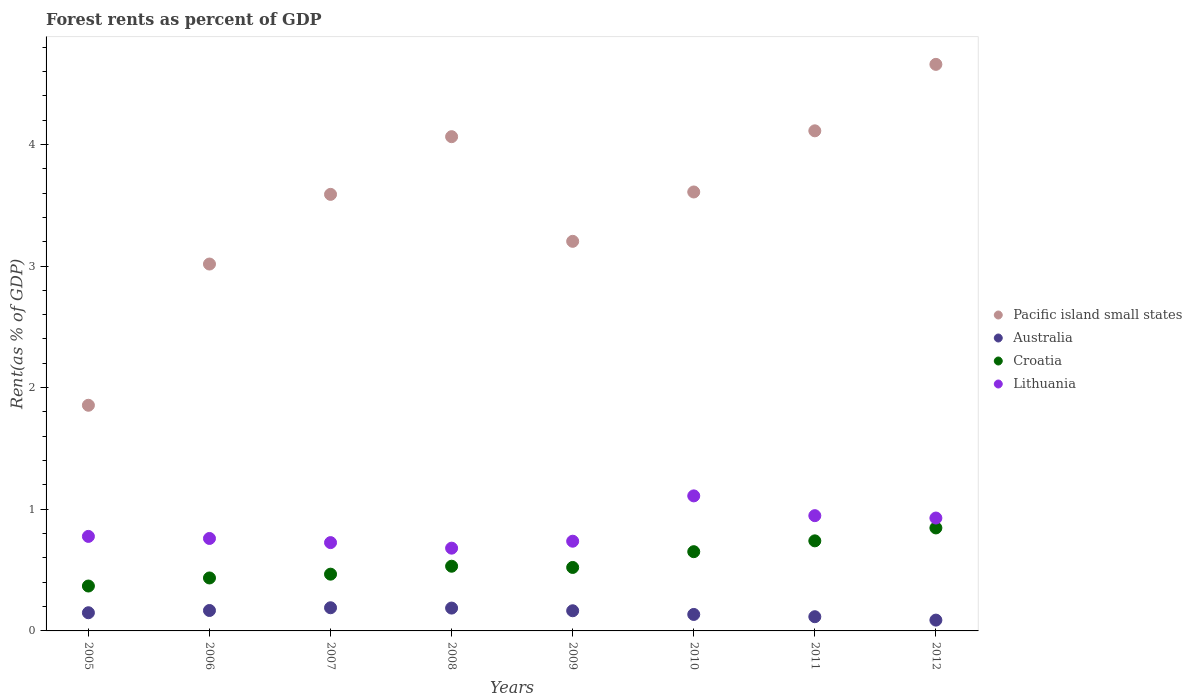How many different coloured dotlines are there?
Offer a very short reply. 4. Is the number of dotlines equal to the number of legend labels?
Keep it short and to the point. Yes. What is the forest rent in Pacific island small states in 2008?
Make the answer very short. 4.06. Across all years, what is the maximum forest rent in Australia?
Your response must be concise. 0.19. Across all years, what is the minimum forest rent in Lithuania?
Offer a very short reply. 0.68. In which year was the forest rent in Pacific island small states maximum?
Provide a short and direct response. 2012. In which year was the forest rent in Lithuania minimum?
Keep it short and to the point. 2008. What is the total forest rent in Lithuania in the graph?
Your response must be concise. 6.67. What is the difference between the forest rent in Lithuania in 2005 and that in 2010?
Offer a very short reply. -0.33. What is the difference between the forest rent in Lithuania in 2005 and the forest rent in Pacific island small states in 2009?
Give a very brief answer. -2.43. What is the average forest rent in Croatia per year?
Keep it short and to the point. 0.57. In the year 2008, what is the difference between the forest rent in Australia and forest rent in Pacific island small states?
Your answer should be very brief. -3.88. What is the ratio of the forest rent in Australia in 2005 to that in 2010?
Provide a succinct answer. 1.1. Is the difference between the forest rent in Australia in 2005 and 2010 greater than the difference between the forest rent in Pacific island small states in 2005 and 2010?
Give a very brief answer. Yes. What is the difference between the highest and the second highest forest rent in Pacific island small states?
Keep it short and to the point. 0.55. What is the difference between the highest and the lowest forest rent in Pacific island small states?
Offer a very short reply. 2.8. In how many years, is the forest rent in Croatia greater than the average forest rent in Croatia taken over all years?
Ensure brevity in your answer.  3. Is the sum of the forest rent in Pacific island small states in 2009 and 2011 greater than the maximum forest rent in Lithuania across all years?
Give a very brief answer. Yes. Is it the case that in every year, the sum of the forest rent in Australia and forest rent in Croatia  is greater than the sum of forest rent in Lithuania and forest rent in Pacific island small states?
Provide a succinct answer. No. Is the forest rent in Pacific island small states strictly greater than the forest rent in Lithuania over the years?
Provide a succinct answer. Yes. How many dotlines are there?
Your answer should be very brief. 4. Are the values on the major ticks of Y-axis written in scientific E-notation?
Your answer should be compact. No. Does the graph contain any zero values?
Keep it short and to the point. No. Where does the legend appear in the graph?
Keep it short and to the point. Center right. What is the title of the graph?
Provide a succinct answer. Forest rents as percent of GDP. What is the label or title of the Y-axis?
Your answer should be very brief. Rent(as % of GDP). What is the Rent(as % of GDP) of Pacific island small states in 2005?
Ensure brevity in your answer.  1.86. What is the Rent(as % of GDP) in Australia in 2005?
Provide a succinct answer. 0.15. What is the Rent(as % of GDP) of Croatia in 2005?
Your response must be concise. 0.37. What is the Rent(as % of GDP) of Lithuania in 2005?
Offer a very short reply. 0.78. What is the Rent(as % of GDP) in Pacific island small states in 2006?
Your answer should be very brief. 3.02. What is the Rent(as % of GDP) of Australia in 2006?
Provide a short and direct response. 0.17. What is the Rent(as % of GDP) in Croatia in 2006?
Make the answer very short. 0.44. What is the Rent(as % of GDP) in Lithuania in 2006?
Give a very brief answer. 0.76. What is the Rent(as % of GDP) in Pacific island small states in 2007?
Your response must be concise. 3.59. What is the Rent(as % of GDP) in Australia in 2007?
Offer a very short reply. 0.19. What is the Rent(as % of GDP) in Croatia in 2007?
Provide a succinct answer. 0.47. What is the Rent(as % of GDP) in Lithuania in 2007?
Offer a terse response. 0.73. What is the Rent(as % of GDP) in Pacific island small states in 2008?
Provide a succinct answer. 4.06. What is the Rent(as % of GDP) of Australia in 2008?
Make the answer very short. 0.19. What is the Rent(as % of GDP) of Croatia in 2008?
Your response must be concise. 0.53. What is the Rent(as % of GDP) of Lithuania in 2008?
Your response must be concise. 0.68. What is the Rent(as % of GDP) in Pacific island small states in 2009?
Your answer should be compact. 3.2. What is the Rent(as % of GDP) of Australia in 2009?
Provide a short and direct response. 0.17. What is the Rent(as % of GDP) of Croatia in 2009?
Keep it short and to the point. 0.52. What is the Rent(as % of GDP) in Lithuania in 2009?
Make the answer very short. 0.74. What is the Rent(as % of GDP) in Pacific island small states in 2010?
Provide a succinct answer. 3.61. What is the Rent(as % of GDP) in Australia in 2010?
Provide a short and direct response. 0.14. What is the Rent(as % of GDP) in Croatia in 2010?
Give a very brief answer. 0.65. What is the Rent(as % of GDP) in Lithuania in 2010?
Provide a short and direct response. 1.11. What is the Rent(as % of GDP) of Pacific island small states in 2011?
Give a very brief answer. 4.11. What is the Rent(as % of GDP) of Australia in 2011?
Provide a succinct answer. 0.12. What is the Rent(as % of GDP) of Croatia in 2011?
Provide a short and direct response. 0.74. What is the Rent(as % of GDP) in Lithuania in 2011?
Ensure brevity in your answer.  0.95. What is the Rent(as % of GDP) of Pacific island small states in 2012?
Offer a very short reply. 4.66. What is the Rent(as % of GDP) in Australia in 2012?
Your answer should be compact. 0.09. What is the Rent(as % of GDP) of Croatia in 2012?
Give a very brief answer. 0.85. What is the Rent(as % of GDP) of Lithuania in 2012?
Your answer should be very brief. 0.93. Across all years, what is the maximum Rent(as % of GDP) in Pacific island small states?
Your response must be concise. 4.66. Across all years, what is the maximum Rent(as % of GDP) of Australia?
Ensure brevity in your answer.  0.19. Across all years, what is the maximum Rent(as % of GDP) of Croatia?
Your answer should be compact. 0.85. Across all years, what is the maximum Rent(as % of GDP) of Lithuania?
Provide a short and direct response. 1.11. Across all years, what is the minimum Rent(as % of GDP) of Pacific island small states?
Offer a terse response. 1.86. Across all years, what is the minimum Rent(as % of GDP) in Australia?
Ensure brevity in your answer.  0.09. Across all years, what is the minimum Rent(as % of GDP) of Croatia?
Your response must be concise. 0.37. Across all years, what is the minimum Rent(as % of GDP) of Lithuania?
Your answer should be very brief. 0.68. What is the total Rent(as % of GDP) of Pacific island small states in the graph?
Provide a short and direct response. 28.1. What is the total Rent(as % of GDP) in Australia in the graph?
Ensure brevity in your answer.  1.2. What is the total Rent(as % of GDP) of Croatia in the graph?
Keep it short and to the point. 4.56. What is the total Rent(as % of GDP) of Lithuania in the graph?
Provide a short and direct response. 6.67. What is the difference between the Rent(as % of GDP) of Pacific island small states in 2005 and that in 2006?
Provide a short and direct response. -1.16. What is the difference between the Rent(as % of GDP) in Australia in 2005 and that in 2006?
Give a very brief answer. -0.02. What is the difference between the Rent(as % of GDP) in Croatia in 2005 and that in 2006?
Offer a terse response. -0.07. What is the difference between the Rent(as % of GDP) in Lithuania in 2005 and that in 2006?
Offer a terse response. 0.02. What is the difference between the Rent(as % of GDP) of Pacific island small states in 2005 and that in 2007?
Your response must be concise. -1.73. What is the difference between the Rent(as % of GDP) in Australia in 2005 and that in 2007?
Keep it short and to the point. -0.04. What is the difference between the Rent(as % of GDP) of Croatia in 2005 and that in 2007?
Provide a short and direct response. -0.1. What is the difference between the Rent(as % of GDP) of Lithuania in 2005 and that in 2007?
Give a very brief answer. 0.05. What is the difference between the Rent(as % of GDP) in Pacific island small states in 2005 and that in 2008?
Your answer should be very brief. -2.21. What is the difference between the Rent(as % of GDP) in Australia in 2005 and that in 2008?
Provide a short and direct response. -0.04. What is the difference between the Rent(as % of GDP) in Croatia in 2005 and that in 2008?
Offer a terse response. -0.16. What is the difference between the Rent(as % of GDP) in Lithuania in 2005 and that in 2008?
Keep it short and to the point. 0.1. What is the difference between the Rent(as % of GDP) in Pacific island small states in 2005 and that in 2009?
Offer a terse response. -1.35. What is the difference between the Rent(as % of GDP) in Australia in 2005 and that in 2009?
Offer a very short reply. -0.02. What is the difference between the Rent(as % of GDP) in Croatia in 2005 and that in 2009?
Provide a succinct answer. -0.15. What is the difference between the Rent(as % of GDP) of Lithuania in 2005 and that in 2009?
Your answer should be compact. 0.04. What is the difference between the Rent(as % of GDP) in Pacific island small states in 2005 and that in 2010?
Offer a very short reply. -1.75. What is the difference between the Rent(as % of GDP) of Australia in 2005 and that in 2010?
Keep it short and to the point. 0.01. What is the difference between the Rent(as % of GDP) of Croatia in 2005 and that in 2010?
Offer a terse response. -0.28. What is the difference between the Rent(as % of GDP) in Lithuania in 2005 and that in 2010?
Offer a very short reply. -0.33. What is the difference between the Rent(as % of GDP) of Pacific island small states in 2005 and that in 2011?
Ensure brevity in your answer.  -2.26. What is the difference between the Rent(as % of GDP) of Australia in 2005 and that in 2011?
Your answer should be compact. 0.03. What is the difference between the Rent(as % of GDP) in Croatia in 2005 and that in 2011?
Your answer should be very brief. -0.37. What is the difference between the Rent(as % of GDP) of Lithuania in 2005 and that in 2011?
Give a very brief answer. -0.17. What is the difference between the Rent(as % of GDP) in Pacific island small states in 2005 and that in 2012?
Your answer should be very brief. -2.8. What is the difference between the Rent(as % of GDP) in Australia in 2005 and that in 2012?
Provide a short and direct response. 0.06. What is the difference between the Rent(as % of GDP) in Croatia in 2005 and that in 2012?
Your response must be concise. -0.48. What is the difference between the Rent(as % of GDP) in Lithuania in 2005 and that in 2012?
Your answer should be compact. -0.15. What is the difference between the Rent(as % of GDP) of Pacific island small states in 2006 and that in 2007?
Provide a short and direct response. -0.57. What is the difference between the Rent(as % of GDP) in Australia in 2006 and that in 2007?
Give a very brief answer. -0.02. What is the difference between the Rent(as % of GDP) of Croatia in 2006 and that in 2007?
Provide a succinct answer. -0.03. What is the difference between the Rent(as % of GDP) in Lithuania in 2006 and that in 2007?
Provide a succinct answer. 0.03. What is the difference between the Rent(as % of GDP) of Pacific island small states in 2006 and that in 2008?
Your answer should be very brief. -1.05. What is the difference between the Rent(as % of GDP) of Australia in 2006 and that in 2008?
Provide a succinct answer. -0.02. What is the difference between the Rent(as % of GDP) in Croatia in 2006 and that in 2008?
Your answer should be compact. -0.1. What is the difference between the Rent(as % of GDP) of Lithuania in 2006 and that in 2008?
Offer a terse response. 0.08. What is the difference between the Rent(as % of GDP) of Pacific island small states in 2006 and that in 2009?
Your response must be concise. -0.19. What is the difference between the Rent(as % of GDP) of Australia in 2006 and that in 2009?
Offer a very short reply. 0. What is the difference between the Rent(as % of GDP) in Croatia in 2006 and that in 2009?
Keep it short and to the point. -0.09. What is the difference between the Rent(as % of GDP) in Lithuania in 2006 and that in 2009?
Offer a terse response. 0.02. What is the difference between the Rent(as % of GDP) of Pacific island small states in 2006 and that in 2010?
Give a very brief answer. -0.59. What is the difference between the Rent(as % of GDP) in Australia in 2006 and that in 2010?
Ensure brevity in your answer.  0.03. What is the difference between the Rent(as % of GDP) in Croatia in 2006 and that in 2010?
Give a very brief answer. -0.22. What is the difference between the Rent(as % of GDP) of Lithuania in 2006 and that in 2010?
Your answer should be very brief. -0.35. What is the difference between the Rent(as % of GDP) in Pacific island small states in 2006 and that in 2011?
Make the answer very short. -1.1. What is the difference between the Rent(as % of GDP) of Australia in 2006 and that in 2011?
Your response must be concise. 0.05. What is the difference between the Rent(as % of GDP) of Croatia in 2006 and that in 2011?
Your response must be concise. -0.31. What is the difference between the Rent(as % of GDP) in Lithuania in 2006 and that in 2011?
Keep it short and to the point. -0.19. What is the difference between the Rent(as % of GDP) of Pacific island small states in 2006 and that in 2012?
Offer a very short reply. -1.64. What is the difference between the Rent(as % of GDP) in Australia in 2006 and that in 2012?
Your answer should be compact. 0.08. What is the difference between the Rent(as % of GDP) in Croatia in 2006 and that in 2012?
Keep it short and to the point. -0.41. What is the difference between the Rent(as % of GDP) in Lithuania in 2006 and that in 2012?
Your answer should be very brief. -0.17. What is the difference between the Rent(as % of GDP) of Pacific island small states in 2007 and that in 2008?
Offer a very short reply. -0.47. What is the difference between the Rent(as % of GDP) in Australia in 2007 and that in 2008?
Your answer should be compact. 0. What is the difference between the Rent(as % of GDP) in Croatia in 2007 and that in 2008?
Keep it short and to the point. -0.07. What is the difference between the Rent(as % of GDP) in Lithuania in 2007 and that in 2008?
Ensure brevity in your answer.  0.05. What is the difference between the Rent(as % of GDP) of Pacific island small states in 2007 and that in 2009?
Your answer should be compact. 0.39. What is the difference between the Rent(as % of GDP) in Australia in 2007 and that in 2009?
Offer a terse response. 0.02. What is the difference between the Rent(as % of GDP) in Croatia in 2007 and that in 2009?
Offer a terse response. -0.06. What is the difference between the Rent(as % of GDP) in Lithuania in 2007 and that in 2009?
Offer a terse response. -0.01. What is the difference between the Rent(as % of GDP) of Pacific island small states in 2007 and that in 2010?
Keep it short and to the point. -0.02. What is the difference between the Rent(as % of GDP) of Australia in 2007 and that in 2010?
Your response must be concise. 0.06. What is the difference between the Rent(as % of GDP) in Croatia in 2007 and that in 2010?
Provide a short and direct response. -0.18. What is the difference between the Rent(as % of GDP) in Lithuania in 2007 and that in 2010?
Make the answer very short. -0.38. What is the difference between the Rent(as % of GDP) in Pacific island small states in 2007 and that in 2011?
Keep it short and to the point. -0.52. What is the difference between the Rent(as % of GDP) of Australia in 2007 and that in 2011?
Ensure brevity in your answer.  0.07. What is the difference between the Rent(as % of GDP) in Croatia in 2007 and that in 2011?
Your response must be concise. -0.27. What is the difference between the Rent(as % of GDP) in Lithuania in 2007 and that in 2011?
Your response must be concise. -0.22. What is the difference between the Rent(as % of GDP) in Pacific island small states in 2007 and that in 2012?
Your answer should be compact. -1.07. What is the difference between the Rent(as % of GDP) in Australia in 2007 and that in 2012?
Your answer should be very brief. 0.1. What is the difference between the Rent(as % of GDP) in Croatia in 2007 and that in 2012?
Provide a short and direct response. -0.38. What is the difference between the Rent(as % of GDP) of Lithuania in 2007 and that in 2012?
Your response must be concise. -0.2. What is the difference between the Rent(as % of GDP) of Pacific island small states in 2008 and that in 2009?
Ensure brevity in your answer.  0.86. What is the difference between the Rent(as % of GDP) of Australia in 2008 and that in 2009?
Offer a very short reply. 0.02. What is the difference between the Rent(as % of GDP) of Croatia in 2008 and that in 2009?
Your response must be concise. 0.01. What is the difference between the Rent(as % of GDP) in Lithuania in 2008 and that in 2009?
Offer a terse response. -0.06. What is the difference between the Rent(as % of GDP) in Pacific island small states in 2008 and that in 2010?
Ensure brevity in your answer.  0.45. What is the difference between the Rent(as % of GDP) of Australia in 2008 and that in 2010?
Offer a very short reply. 0.05. What is the difference between the Rent(as % of GDP) of Croatia in 2008 and that in 2010?
Your response must be concise. -0.12. What is the difference between the Rent(as % of GDP) in Lithuania in 2008 and that in 2010?
Ensure brevity in your answer.  -0.43. What is the difference between the Rent(as % of GDP) in Pacific island small states in 2008 and that in 2011?
Make the answer very short. -0.05. What is the difference between the Rent(as % of GDP) in Australia in 2008 and that in 2011?
Provide a succinct answer. 0.07. What is the difference between the Rent(as % of GDP) in Croatia in 2008 and that in 2011?
Provide a short and direct response. -0.21. What is the difference between the Rent(as % of GDP) in Lithuania in 2008 and that in 2011?
Offer a terse response. -0.27. What is the difference between the Rent(as % of GDP) in Pacific island small states in 2008 and that in 2012?
Your answer should be compact. -0.59. What is the difference between the Rent(as % of GDP) in Australia in 2008 and that in 2012?
Your answer should be compact. 0.1. What is the difference between the Rent(as % of GDP) of Croatia in 2008 and that in 2012?
Your answer should be very brief. -0.31. What is the difference between the Rent(as % of GDP) in Lithuania in 2008 and that in 2012?
Provide a short and direct response. -0.25. What is the difference between the Rent(as % of GDP) of Pacific island small states in 2009 and that in 2010?
Give a very brief answer. -0.41. What is the difference between the Rent(as % of GDP) of Australia in 2009 and that in 2010?
Provide a short and direct response. 0.03. What is the difference between the Rent(as % of GDP) in Croatia in 2009 and that in 2010?
Keep it short and to the point. -0.13. What is the difference between the Rent(as % of GDP) of Lithuania in 2009 and that in 2010?
Provide a succinct answer. -0.37. What is the difference between the Rent(as % of GDP) in Pacific island small states in 2009 and that in 2011?
Your answer should be very brief. -0.91. What is the difference between the Rent(as % of GDP) in Australia in 2009 and that in 2011?
Your answer should be compact. 0.05. What is the difference between the Rent(as % of GDP) of Croatia in 2009 and that in 2011?
Offer a very short reply. -0.22. What is the difference between the Rent(as % of GDP) in Lithuania in 2009 and that in 2011?
Provide a succinct answer. -0.21. What is the difference between the Rent(as % of GDP) in Pacific island small states in 2009 and that in 2012?
Provide a succinct answer. -1.45. What is the difference between the Rent(as % of GDP) of Australia in 2009 and that in 2012?
Make the answer very short. 0.08. What is the difference between the Rent(as % of GDP) of Croatia in 2009 and that in 2012?
Your answer should be compact. -0.32. What is the difference between the Rent(as % of GDP) of Lithuania in 2009 and that in 2012?
Keep it short and to the point. -0.19. What is the difference between the Rent(as % of GDP) of Pacific island small states in 2010 and that in 2011?
Provide a succinct answer. -0.5. What is the difference between the Rent(as % of GDP) in Australia in 2010 and that in 2011?
Give a very brief answer. 0.02. What is the difference between the Rent(as % of GDP) of Croatia in 2010 and that in 2011?
Make the answer very short. -0.09. What is the difference between the Rent(as % of GDP) in Lithuania in 2010 and that in 2011?
Give a very brief answer. 0.16. What is the difference between the Rent(as % of GDP) in Pacific island small states in 2010 and that in 2012?
Keep it short and to the point. -1.05. What is the difference between the Rent(as % of GDP) of Australia in 2010 and that in 2012?
Provide a short and direct response. 0.05. What is the difference between the Rent(as % of GDP) in Croatia in 2010 and that in 2012?
Provide a short and direct response. -0.2. What is the difference between the Rent(as % of GDP) of Lithuania in 2010 and that in 2012?
Your answer should be very brief. 0.18. What is the difference between the Rent(as % of GDP) of Pacific island small states in 2011 and that in 2012?
Your response must be concise. -0.55. What is the difference between the Rent(as % of GDP) of Australia in 2011 and that in 2012?
Give a very brief answer. 0.03. What is the difference between the Rent(as % of GDP) of Croatia in 2011 and that in 2012?
Offer a very short reply. -0.11. What is the difference between the Rent(as % of GDP) in Lithuania in 2011 and that in 2012?
Ensure brevity in your answer.  0.02. What is the difference between the Rent(as % of GDP) of Pacific island small states in 2005 and the Rent(as % of GDP) of Australia in 2006?
Your answer should be very brief. 1.69. What is the difference between the Rent(as % of GDP) in Pacific island small states in 2005 and the Rent(as % of GDP) in Croatia in 2006?
Provide a succinct answer. 1.42. What is the difference between the Rent(as % of GDP) in Pacific island small states in 2005 and the Rent(as % of GDP) in Lithuania in 2006?
Provide a short and direct response. 1.1. What is the difference between the Rent(as % of GDP) of Australia in 2005 and the Rent(as % of GDP) of Croatia in 2006?
Ensure brevity in your answer.  -0.29. What is the difference between the Rent(as % of GDP) in Australia in 2005 and the Rent(as % of GDP) in Lithuania in 2006?
Ensure brevity in your answer.  -0.61. What is the difference between the Rent(as % of GDP) of Croatia in 2005 and the Rent(as % of GDP) of Lithuania in 2006?
Offer a terse response. -0.39. What is the difference between the Rent(as % of GDP) of Pacific island small states in 2005 and the Rent(as % of GDP) of Australia in 2007?
Make the answer very short. 1.66. What is the difference between the Rent(as % of GDP) in Pacific island small states in 2005 and the Rent(as % of GDP) in Croatia in 2007?
Make the answer very short. 1.39. What is the difference between the Rent(as % of GDP) of Pacific island small states in 2005 and the Rent(as % of GDP) of Lithuania in 2007?
Ensure brevity in your answer.  1.13. What is the difference between the Rent(as % of GDP) in Australia in 2005 and the Rent(as % of GDP) in Croatia in 2007?
Give a very brief answer. -0.32. What is the difference between the Rent(as % of GDP) of Australia in 2005 and the Rent(as % of GDP) of Lithuania in 2007?
Provide a short and direct response. -0.58. What is the difference between the Rent(as % of GDP) in Croatia in 2005 and the Rent(as % of GDP) in Lithuania in 2007?
Ensure brevity in your answer.  -0.36. What is the difference between the Rent(as % of GDP) in Pacific island small states in 2005 and the Rent(as % of GDP) in Australia in 2008?
Your answer should be very brief. 1.67. What is the difference between the Rent(as % of GDP) of Pacific island small states in 2005 and the Rent(as % of GDP) of Croatia in 2008?
Your response must be concise. 1.32. What is the difference between the Rent(as % of GDP) in Pacific island small states in 2005 and the Rent(as % of GDP) in Lithuania in 2008?
Your answer should be very brief. 1.17. What is the difference between the Rent(as % of GDP) in Australia in 2005 and the Rent(as % of GDP) in Croatia in 2008?
Provide a short and direct response. -0.38. What is the difference between the Rent(as % of GDP) in Australia in 2005 and the Rent(as % of GDP) in Lithuania in 2008?
Your answer should be compact. -0.53. What is the difference between the Rent(as % of GDP) of Croatia in 2005 and the Rent(as % of GDP) of Lithuania in 2008?
Your response must be concise. -0.31. What is the difference between the Rent(as % of GDP) of Pacific island small states in 2005 and the Rent(as % of GDP) of Australia in 2009?
Give a very brief answer. 1.69. What is the difference between the Rent(as % of GDP) of Pacific island small states in 2005 and the Rent(as % of GDP) of Croatia in 2009?
Offer a very short reply. 1.33. What is the difference between the Rent(as % of GDP) in Pacific island small states in 2005 and the Rent(as % of GDP) in Lithuania in 2009?
Your answer should be compact. 1.12. What is the difference between the Rent(as % of GDP) of Australia in 2005 and the Rent(as % of GDP) of Croatia in 2009?
Provide a succinct answer. -0.37. What is the difference between the Rent(as % of GDP) in Australia in 2005 and the Rent(as % of GDP) in Lithuania in 2009?
Your answer should be compact. -0.59. What is the difference between the Rent(as % of GDP) of Croatia in 2005 and the Rent(as % of GDP) of Lithuania in 2009?
Your answer should be very brief. -0.37. What is the difference between the Rent(as % of GDP) of Pacific island small states in 2005 and the Rent(as % of GDP) of Australia in 2010?
Provide a short and direct response. 1.72. What is the difference between the Rent(as % of GDP) of Pacific island small states in 2005 and the Rent(as % of GDP) of Croatia in 2010?
Offer a very short reply. 1.2. What is the difference between the Rent(as % of GDP) of Pacific island small states in 2005 and the Rent(as % of GDP) of Lithuania in 2010?
Your response must be concise. 0.74. What is the difference between the Rent(as % of GDP) in Australia in 2005 and the Rent(as % of GDP) in Croatia in 2010?
Offer a very short reply. -0.5. What is the difference between the Rent(as % of GDP) in Australia in 2005 and the Rent(as % of GDP) in Lithuania in 2010?
Give a very brief answer. -0.96. What is the difference between the Rent(as % of GDP) of Croatia in 2005 and the Rent(as % of GDP) of Lithuania in 2010?
Provide a succinct answer. -0.74. What is the difference between the Rent(as % of GDP) of Pacific island small states in 2005 and the Rent(as % of GDP) of Australia in 2011?
Offer a terse response. 1.74. What is the difference between the Rent(as % of GDP) in Pacific island small states in 2005 and the Rent(as % of GDP) in Croatia in 2011?
Offer a terse response. 1.11. What is the difference between the Rent(as % of GDP) of Pacific island small states in 2005 and the Rent(as % of GDP) of Lithuania in 2011?
Offer a terse response. 0.91. What is the difference between the Rent(as % of GDP) of Australia in 2005 and the Rent(as % of GDP) of Croatia in 2011?
Your response must be concise. -0.59. What is the difference between the Rent(as % of GDP) of Australia in 2005 and the Rent(as % of GDP) of Lithuania in 2011?
Your answer should be very brief. -0.8. What is the difference between the Rent(as % of GDP) of Croatia in 2005 and the Rent(as % of GDP) of Lithuania in 2011?
Ensure brevity in your answer.  -0.58. What is the difference between the Rent(as % of GDP) of Pacific island small states in 2005 and the Rent(as % of GDP) of Australia in 2012?
Make the answer very short. 1.77. What is the difference between the Rent(as % of GDP) in Pacific island small states in 2005 and the Rent(as % of GDP) in Croatia in 2012?
Your answer should be very brief. 1.01. What is the difference between the Rent(as % of GDP) of Pacific island small states in 2005 and the Rent(as % of GDP) of Lithuania in 2012?
Offer a very short reply. 0.93. What is the difference between the Rent(as % of GDP) in Australia in 2005 and the Rent(as % of GDP) in Croatia in 2012?
Your response must be concise. -0.7. What is the difference between the Rent(as % of GDP) of Australia in 2005 and the Rent(as % of GDP) of Lithuania in 2012?
Your answer should be very brief. -0.78. What is the difference between the Rent(as % of GDP) of Croatia in 2005 and the Rent(as % of GDP) of Lithuania in 2012?
Keep it short and to the point. -0.56. What is the difference between the Rent(as % of GDP) of Pacific island small states in 2006 and the Rent(as % of GDP) of Australia in 2007?
Your answer should be compact. 2.83. What is the difference between the Rent(as % of GDP) in Pacific island small states in 2006 and the Rent(as % of GDP) in Croatia in 2007?
Give a very brief answer. 2.55. What is the difference between the Rent(as % of GDP) in Pacific island small states in 2006 and the Rent(as % of GDP) in Lithuania in 2007?
Offer a very short reply. 2.29. What is the difference between the Rent(as % of GDP) of Australia in 2006 and the Rent(as % of GDP) of Croatia in 2007?
Your answer should be compact. -0.3. What is the difference between the Rent(as % of GDP) of Australia in 2006 and the Rent(as % of GDP) of Lithuania in 2007?
Your response must be concise. -0.56. What is the difference between the Rent(as % of GDP) of Croatia in 2006 and the Rent(as % of GDP) of Lithuania in 2007?
Your answer should be compact. -0.29. What is the difference between the Rent(as % of GDP) of Pacific island small states in 2006 and the Rent(as % of GDP) of Australia in 2008?
Offer a very short reply. 2.83. What is the difference between the Rent(as % of GDP) of Pacific island small states in 2006 and the Rent(as % of GDP) of Croatia in 2008?
Provide a succinct answer. 2.48. What is the difference between the Rent(as % of GDP) in Pacific island small states in 2006 and the Rent(as % of GDP) in Lithuania in 2008?
Provide a short and direct response. 2.34. What is the difference between the Rent(as % of GDP) of Australia in 2006 and the Rent(as % of GDP) of Croatia in 2008?
Provide a succinct answer. -0.36. What is the difference between the Rent(as % of GDP) in Australia in 2006 and the Rent(as % of GDP) in Lithuania in 2008?
Offer a terse response. -0.51. What is the difference between the Rent(as % of GDP) of Croatia in 2006 and the Rent(as % of GDP) of Lithuania in 2008?
Provide a succinct answer. -0.24. What is the difference between the Rent(as % of GDP) of Pacific island small states in 2006 and the Rent(as % of GDP) of Australia in 2009?
Make the answer very short. 2.85. What is the difference between the Rent(as % of GDP) in Pacific island small states in 2006 and the Rent(as % of GDP) in Croatia in 2009?
Make the answer very short. 2.49. What is the difference between the Rent(as % of GDP) in Pacific island small states in 2006 and the Rent(as % of GDP) in Lithuania in 2009?
Make the answer very short. 2.28. What is the difference between the Rent(as % of GDP) of Australia in 2006 and the Rent(as % of GDP) of Croatia in 2009?
Ensure brevity in your answer.  -0.35. What is the difference between the Rent(as % of GDP) in Australia in 2006 and the Rent(as % of GDP) in Lithuania in 2009?
Your answer should be very brief. -0.57. What is the difference between the Rent(as % of GDP) in Croatia in 2006 and the Rent(as % of GDP) in Lithuania in 2009?
Your answer should be very brief. -0.3. What is the difference between the Rent(as % of GDP) of Pacific island small states in 2006 and the Rent(as % of GDP) of Australia in 2010?
Give a very brief answer. 2.88. What is the difference between the Rent(as % of GDP) in Pacific island small states in 2006 and the Rent(as % of GDP) in Croatia in 2010?
Give a very brief answer. 2.36. What is the difference between the Rent(as % of GDP) in Pacific island small states in 2006 and the Rent(as % of GDP) in Lithuania in 2010?
Your answer should be very brief. 1.91. What is the difference between the Rent(as % of GDP) in Australia in 2006 and the Rent(as % of GDP) in Croatia in 2010?
Keep it short and to the point. -0.48. What is the difference between the Rent(as % of GDP) of Australia in 2006 and the Rent(as % of GDP) of Lithuania in 2010?
Offer a very short reply. -0.94. What is the difference between the Rent(as % of GDP) in Croatia in 2006 and the Rent(as % of GDP) in Lithuania in 2010?
Offer a very short reply. -0.67. What is the difference between the Rent(as % of GDP) of Pacific island small states in 2006 and the Rent(as % of GDP) of Australia in 2011?
Give a very brief answer. 2.9. What is the difference between the Rent(as % of GDP) of Pacific island small states in 2006 and the Rent(as % of GDP) of Croatia in 2011?
Ensure brevity in your answer.  2.28. What is the difference between the Rent(as % of GDP) of Pacific island small states in 2006 and the Rent(as % of GDP) of Lithuania in 2011?
Keep it short and to the point. 2.07. What is the difference between the Rent(as % of GDP) of Australia in 2006 and the Rent(as % of GDP) of Croatia in 2011?
Offer a very short reply. -0.57. What is the difference between the Rent(as % of GDP) of Australia in 2006 and the Rent(as % of GDP) of Lithuania in 2011?
Ensure brevity in your answer.  -0.78. What is the difference between the Rent(as % of GDP) in Croatia in 2006 and the Rent(as % of GDP) in Lithuania in 2011?
Offer a very short reply. -0.51. What is the difference between the Rent(as % of GDP) of Pacific island small states in 2006 and the Rent(as % of GDP) of Australia in 2012?
Make the answer very short. 2.93. What is the difference between the Rent(as % of GDP) in Pacific island small states in 2006 and the Rent(as % of GDP) in Croatia in 2012?
Your answer should be compact. 2.17. What is the difference between the Rent(as % of GDP) of Pacific island small states in 2006 and the Rent(as % of GDP) of Lithuania in 2012?
Keep it short and to the point. 2.09. What is the difference between the Rent(as % of GDP) of Australia in 2006 and the Rent(as % of GDP) of Croatia in 2012?
Make the answer very short. -0.68. What is the difference between the Rent(as % of GDP) in Australia in 2006 and the Rent(as % of GDP) in Lithuania in 2012?
Your response must be concise. -0.76. What is the difference between the Rent(as % of GDP) in Croatia in 2006 and the Rent(as % of GDP) in Lithuania in 2012?
Offer a terse response. -0.49. What is the difference between the Rent(as % of GDP) in Pacific island small states in 2007 and the Rent(as % of GDP) in Australia in 2008?
Offer a terse response. 3.4. What is the difference between the Rent(as % of GDP) in Pacific island small states in 2007 and the Rent(as % of GDP) in Croatia in 2008?
Your answer should be compact. 3.06. What is the difference between the Rent(as % of GDP) in Pacific island small states in 2007 and the Rent(as % of GDP) in Lithuania in 2008?
Offer a terse response. 2.91. What is the difference between the Rent(as % of GDP) in Australia in 2007 and the Rent(as % of GDP) in Croatia in 2008?
Ensure brevity in your answer.  -0.34. What is the difference between the Rent(as % of GDP) of Australia in 2007 and the Rent(as % of GDP) of Lithuania in 2008?
Keep it short and to the point. -0.49. What is the difference between the Rent(as % of GDP) of Croatia in 2007 and the Rent(as % of GDP) of Lithuania in 2008?
Your answer should be very brief. -0.21. What is the difference between the Rent(as % of GDP) in Pacific island small states in 2007 and the Rent(as % of GDP) in Australia in 2009?
Provide a short and direct response. 3.42. What is the difference between the Rent(as % of GDP) of Pacific island small states in 2007 and the Rent(as % of GDP) of Croatia in 2009?
Your response must be concise. 3.07. What is the difference between the Rent(as % of GDP) in Pacific island small states in 2007 and the Rent(as % of GDP) in Lithuania in 2009?
Give a very brief answer. 2.85. What is the difference between the Rent(as % of GDP) of Australia in 2007 and the Rent(as % of GDP) of Croatia in 2009?
Provide a succinct answer. -0.33. What is the difference between the Rent(as % of GDP) of Australia in 2007 and the Rent(as % of GDP) of Lithuania in 2009?
Your response must be concise. -0.55. What is the difference between the Rent(as % of GDP) in Croatia in 2007 and the Rent(as % of GDP) in Lithuania in 2009?
Your answer should be compact. -0.27. What is the difference between the Rent(as % of GDP) in Pacific island small states in 2007 and the Rent(as % of GDP) in Australia in 2010?
Give a very brief answer. 3.45. What is the difference between the Rent(as % of GDP) in Pacific island small states in 2007 and the Rent(as % of GDP) in Croatia in 2010?
Your answer should be compact. 2.94. What is the difference between the Rent(as % of GDP) in Pacific island small states in 2007 and the Rent(as % of GDP) in Lithuania in 2010?
Your response must be concise. 2.48. What is the difference between the Rent(as % of GDP) in Australia in 2007 and the Rent(as % of GDP) in Croatia in 2010?
Your response must be concise. -0.46. What is the difference between the Rent(as % of GDP) in Australia in 2007 and the Rent(as % of GDP) in Lithuania in 2010?
Provide a succinct answer. -0.92. What is the difference between the Rent(as % of GDP) in Croatia in 2007 and the Rent(as % of GDP) in Lithuania in 2010?
Provide a succinct answer. -0.64. What is the difference between the Rent(as % of GDP) in Pacific island small states in 2007 and the Rent(as % of GDP) in Australia in 2011?
Offer a terse response. 3.47. What is the difference between the Rent(as % of GDP) in Pacific island small states in 2007 and the Rent(as % of GDP) in Croatia in 2011?
Keep it short and to the point. 2.85. What is the difference between the Rent(as % of GDP) of Pacific island small states in 2007 and the Rent(as % of GDP) of Lithuania in 2011?
Give a very brief answer. 2.64. What is the difference between the Rent(as % of GDP) of Australia in 2007 and the Rent(as % of GDP) of Croatia in 2011?
Provide a succinct answer. -0.55. What is the difference between the Rent(as % of GDP) of Australia in 2007 and the Rent(as % of GDP) of Lithuania in 2011?
Provide a succinct answer. -0.76. What is the difference between the Rent(as % of GDP) of Croatia in 2007 and the Rent(as % of GDP) of Lithuania in 2011?
Give a very brief answer. -0.48. What is the difference between the Rent(as % of GDP) in Pacific island small states in 2007 and the Rent(as % of GDP) in Australia in 2012?
Your answer should be compact. 3.5. What is the difference between the Rent(as % of GDP) of Pacific island small states in 2007 and the Rent(as % of GDP) of Croatia in 2012?
Offer a terse response. 2.74. What is the difference between the Rent(as % of GDP) of Pacific island small states in 2007 and the Rent(as % of GDP) of Lithuania in 2012?
Your answer should be compact. 2.66. What is the difference between the Rent(as % of GDP) in Australia in 2007 and the Rent(as % of GDP) in Croatia in 2012?
Ensure brevity in your answer.  -0.66. What is the difference between the Rent(as % of GDP) of Australia in 2007 and the Rent(as % of GDP) of Lithuania in 2012?
Provide a short and direct response. -0.74. What is the difference between the Rent(as % of GDP) in Croatia in 2007 and the Rent(as % of GDP) in Lithuania in 2012?
Your answer should be compact. -0.46. What is the difference between the Rent(as % of GDP) of Pacific island small states in 2008 and the Rent(as % of GDP) of Australia in 2009?
Offer a very short reply. 3.9. What is the difference between the Rent(as % of GDP) of Pacific island small states in 2008 and the Rent(as % of GDP) of Croatia in 2009?
Keep it short and to the point. 3.54. What is the difference between the Rent(as % of GDP) of Pacific island small states in 2008 and the Rent(as % of GDP) of Lithuania in 2009?
Your response must be concise. 3.33. What is the difference between the Rent(as % of GDP) of Australia in 2008 and the Rent(as % of GDP) of Croatia in 2009?
Your response must be concise. -0.33. What is the difference between the Rent(as % of GDP) in Australia in 2008 and the Rent(as % of GDP) in Lithuania in 2009?
Offer a very short reply. -0.55. What is the difference between the Rent(as % of GDP) in Croatia in 2008 and the Rent(as % of GDP) in Lithuania in 2009?
Give a very brief answer. -0.21. What is the difference between the Rent(as % of GDP) in Pacific island small states in 2008 and the Rent(as % of GDP) in Australia in 2010?
Your answer should be very brief. 3.93. What is the difference between the Rent(as % of GDP) of Pacific island small states in 2008 and the Rent(as % of GDP) of Croatia in 2010?
Your answer should be very brief. 3.41. What is the difference between the Rent(as % of GDP) in Pacific island small states in 2008 and the Rent(as % of GDP) in Lithuania in 2010?
Your response must be concise. 2.95. What is the difference between the Rent(as % of GDP) in Australia in 2008 and the Rent(as % of GDP) in Croatia in 2010?
Provide a short and direct response. -0.46. What is the difference between the Rent(as % of GDP) of Australia in 2008 and the Rent(as % of GDP) of Lithuania in 2010?
Keep it short and to the point. -0.92. What is the difference between the Rent(as % of GDP) in Croatia in 2008 and the Rent(as % of GDP) in Lithuania in 2010?
Offer a very short reply. -0.58. What is the difference between the Rent(as % of GDP) in Pacific island small states in 2008 and the Rent(as % of GDP) in Australia in 2011?
Offer a terse response. 3.95. What is the difference between the Rent(as % of GDP) of Pacific island small states in 2008 and the Rent(as % of GDP) of Croatia in 2011?
Your answer should be very brief. 3.32. What is the difference between the Rent(as % of GDP) of Pacific island small states in 2008 and the Rent(as % of GDP) of Lithuania in 2011?
Your answer should be very brief. 3.12. What is the difference between the Rent(as % of GDP) of Australia in 2008 and the Rent(as % of GDP) of Croatia in 2011?
Offer a very short reply. -0.55. What is the difference between the Rent(as % of GDP) of Australia in 2008 and the Rent(as % of GDP) of Lithuania in 2011?
Your answer should be compact. -0.76. What is the difference between the Rent(as % of GDP) in Croatia in 2008 and the Rent(as % of GDP) in Lithuania in 2011?
Offer a very short reply. -0.42. What is the difference between the Rent(as % of GDP) of Pacific island small states in 2008 and the Rent(as % of GDP) of Australia in 2012?
Provide a short and direct response. 3.97. What is the difference between the Rent(as % of GDP) in Pacific island small states in 2008 and the Rent(as % of GDP) in Croatia in 2012?
Offer a terse response. 3.22. What is the difference between the Rent(as % of GDP) in Pacific island small states in 2008 and the Rent(as % of GDP) in Lithuania in 2012?
Make the answer very short. 3.14. What is the difference between the Rent(as % of GDP) of Australia in 2008 and the Rent(as % of GDP) of Croatia in 2012?
Provide a succinct answer. -0.66. What is the difference between the Rent(as % of GDP) of Australia in 2008 and the Rent(as % of GDP) of Lithuania in 2012?
Provide a short and direct response. -0.74. What is the difference between the Rent(as % of GDP) in Croatia in 2008 and the Rent(as % of GDP) in Lithuania in 2012?
Provide a succinct answer. -0.4. What is the difference between the Rent(as % of GDP) in Pacific island small states in 2009 and the Rent(as % of GDP) in Australia in 2010?
Offer a terse response. 3.07. What is the difference between the Rent(as % of GDP) in Pacific island small states in 2009 and the Rent(as % of GDP) in Croatia in 2010?
Your answer should be very brief. 2.55. What is the difference between the Rent(as % of GDP) of Pacific island small states in 2009 and the Rent(as % of GDP) of Lithuania in 2010?
Give a very brief answer. 2.09. What is the difference between the Rent(as % of GDP) in Australia in 2009 and the Rent(as % of GDP) in Croatia in 2010?
Ensure brevity in your answer.  -0.49. What is the difference between the Rent(as % of GDP) of Australia in 2009 and the Rent(as % of GDP) of Lithuania in 2010?
Offer a terse response. -0.94. What is the difference between the Rent(as % of GDP) of Croatia in 2009 and the Rent(as % of GDP) of Lithuania in 2010?
Give a very brief answer. -0.59. What is the difference between the Rent(as % of GDP) of Pacific island small states in 2009 and the Rent(as % of GDP) of Australia in 2011?
Keep it short and to the point. 3.09. What is the difference between the Rent(as % of GDP) of Pacific island small states in 2009 and the Rent(as % of GDP) of Croatia in 2011?
Provide a succinct answer. 2.46. What is the difference between the Rent(as % of GDP) in Pacific island small states in 2009 and the Rent(as % of GDP) in Lithuania in 2011?
Your response must be concise. 2.26. What is the difference between the Rent(as % of GDP) in Australia in 2009 and the Rent(as % of GDP) in Croatia in 2011?
Give a very brief answer. -0.57. What is the difference between the Rent(as % of GDP) in Australia in 2009 and the Rent(as % of GDP) in Lithuania in 2011?
Make the answer very short. -0.78. What is the difference between the Rent(as % of GDP) in Croatia in 2009 and the Rent(as % of GDP) in Lithuania in 2011?
Your answer should be very brief. -0.43. What is the difference between the Rent(as % of GDP) of Pacific island small states in 2009 and the Rent(as % of GDP) of Australia in 2012?
Your answer should be very brief. 3.11. What is the difference between the Rent(as % of GDP) in Pacific island small states in 2009 and the Rent(as % of GDP) in Croatia in 2012?
Your response must be concise. 2.36. What is the difference between the Rent(as % of GDP) of Pacific island small states in 2009 and the Rent(as % of GDP) of Lithuania in 2012?
Your answer should be compact. 2.27. What is the difference between the Rent(as % of GDP) in Australia in 2009 and the Rent(as % of GDP) in Croatia in 2012?
Give a very brief answer. -0.68. What is the difference between the Rent(as % of GDP) in Australia in 2009 and the Rent(as % of GDP) in Lithuania in 2012?
Your answer should be very brief. -0.76. What is the difference between the Rent(as % of GDP) of Croatia in 2009 and the Rent(as % of GDP) of Lithuania in 2012?
Provide a short and direct response. -0.41. What is the difference between the Rent(as % of GDP) of Pacific island small states in 2010 and the Rent(as % of GDP) of Australia in 2011?
Give a very brief answer. 3.49. What is the difference between the Rent(as % of GDP) in Pacific island small states in 2010 and the Rent(as % of GDP) in Croatia in 2011?
Your answer should be compact. 2.87. What is the difference between the Rent(as % of GDP) of Pacific island small states in 2010 and the Rent(as % of GDP) of Lithuania in 2011?
Your answer should be very brief. 2.66. What is the difference between the Rent(as % of GDP) of Australia in 2010 and the Rent(as % of GDP) of Croatia in 2011?
Make the answer very short. -0.61. What is the difference between the Rent(as % of GDP) of Australia in 2010 and the Rent(as % of GDP) of Lithuania in 2011?
Make the answer very short. -0.81. What is the difference between the Rent(as % of GDP) of Croatia in 2010 and the Rent(as % of GDP) of Lithuania in 2011?
Make the answer very short. -0.3. What is the difference between the Rent(as % of GDP) of Pacific island small states in 2010 and the Rent(as % of GDP) of Australia in 2012?
Your answer should be compact. 3.52. What is the difference between the Rent(as % of GDP) of Pacific island small states in 2010 and the Rent(as % of GDP) of Croatia in 2012?
Provide a short and direct response. 2.76. What is the difference between the Rent(as % of GDP) in Pacific island small states in 2010 and the Rent(as % of GDP) in Lithuania in 2012?
Your answer should be compact. 2.68. What is the difference between the Rent(as % of GDP) of Australia in 2010 and the Rent(as % of GDP) of Croatia in 2012?
Keep it short and to the point. -0.71. What is the difference between the Rent(as % of GDP) of Australia in 2010 and the Rent(as % of GDP) of Lithuania in 2012?
Offer a very short reply. -0.79. What is the difference between the Rent(as % of GDP) of Croatia in 2010 and the Rent(as % of GDP) of Lithuania in 2012?
Your answer should be very brief. -0.28. What is the difference between the Rent(as % of GDP) in Pacific island small states in 2011 and the Rent(as % of GDP) in Australia in 2012?
Your response must be concise. 4.02. What is the difference between the Rent(as % of GDP) of Pacific island small states in 2011 and the Rent(as % of GDP) of Croatia in 2012?
Provide a short and direct response. 3.26. What is the difference between the Rent(as % of GDP) of Pacific island small states in 2011 and the Rent(as % of GDP) of Lithuania in 2012?
Give a very brief answer. 3.18. What is the difference between the Rent(as % of GDP) of Australia in 2011 and the Rent(as % of GDP) of Croatia in 2012?
Provide a succinct answer. -0.73. What is the difference between the Rent(as % of GDP) of Australia in 2011 and the Rent(as % of GDP) of Lithuania in 2012?
Offer a terse response. -0.81. What is the difference between the Rent(as % of GDP) in Croatia in 2011 and the Rent(as % of GDP) in Lithuania in 2012?
Provide a succinct answer. -0.19. What is the average Rent(as % of GDP) of Pacific island small states per year?
Keep it short and to the point. 3.51. What is the average Rent(as % of GDP) of Australia per year?
Ensure brevity in your answer.  0.15. What is the average Rent(as % of GDP) of Croatia per year?
Your response must be concise. 0.57. What is the average Rent(as % of GDP) in Lithuania per year?
Make the answer very short. 0.83. In the year 2005, what is the difference between the Rent(as % of GDP) in Pacific island small states and Rent(as % of GDP) in Australia?
Keep it short and to the point. 1.71. In the year 2005, what is the difference between the Rent(as % of GDP) of Pacific island small states and Rent(as % of GDP) of Croatia?
Offer a terse response. 1.49. In the year 2005, what is the difference between the Rent(as % of GDP) of Pacific island small states and Rent(as % of GDP) of Lithuania?
Keep it short and to the point. 1.08. In the year 2005, what is the difference between the Rent(as % of GDP) of Australia and Rent(as % of GDP) of Croatia?
Provide a succinct answer. -0.22. In the year 2005, what is the difference between the Rent(as % of GDP) of Australia and Rent(as % of GDP) of Lithuania?
Provide a short and direct response. -0.63. In the year 2005, what is the difference between the Rent(as % of GDP) in Croatia and Rent(as % of GDP) in Lithuania?
Offer a terse response. -0.41. In the year 2006, what is the difference between the Rent(as % of GDP) in Pacific island small states and Rent(as % of GDP) in Australia?
Provide a succinct answer. 2.85. In the year 2006, what is the difference between the Rent(as % of GDP) of Pacific island small states and Rent(as % of GDP) of Croatia?
Your answer should be compact. 2.58. In the year 2006, what is the difference between the Rent(as % of GDP) in Pacific island small states and Rent(as % of GDP) in Lithuania?
Offer a terse response. 2.26. In the year 2006, what is the difference between the Rent(as % of GDP) of Australia and Rent(as % of GDP) of Croatia?
Provide a succinct answer. -0.27. In the year 2006, what is the difference between the Rent(as % of GDP) of Australia and Rent(as % of GDP) of Lithuania?
Make the answer very short. -0.59. In the year 2006, what is the difference between the Rent(as % of GDP) in Croatia and Rent(as % of GDP) in Lithuania?
Provide a short and direct response. -0.32. In the year 2007, what is the difference between the Rent(as % of GDP) of Pacific island small states and Rent(as % of GDP) of Australia?
Provide a short and direct response. 3.4. In the year 2007, what is the difference between the Rent(as % of GDP) of Pacific island small states and Rent(as % of GDP) of Croatia?
Your response must be concise. 3.12. In the year 2007, what is the difference between the Rent(as % of GDP) in Pacific island small states and Rent(as % of GDP) in Lithuania?
Offer a terse response. 2.86. In the year 2007, what is the difference between the Rent(as % of GDP) in Australia and Rent(as % of GDP) in Croatia?
Keep it short and to the point. -0.28. In the year 2007, what is the difference between the Rent(as % of GDP) in Australia and Rent(as % of GDP) in Lithuania?
Ensure brevity in your answer.  -0.54. In the year 2007, what is the difference between the Rent(as % of GDP) in Croatia and Rent(as % of GDP) in Lithuania?
Your answer should be compact. -0.26. In the year 2008, what is the difference between the Rent(as % of GDP) of Pacific island small states and Rent(as % of GDP) of Australia?
Offer a very short reply. 3.88. In the year 2008, what is the difference between the Rent(as % of GDP) of Pacific island small states and Rent(as % of GDP) of Croatia?
Offer a very short reply. 3.53. In the year 2008, what is the difference between the Rent(as % of GDP) in Pacific island small states and Rent(as % of GDP) in Lithuania?
Offer a terse response. 3.38. In the year 2008, what is the difference between the Rent(as % of GDP) of Australia and Rent(as % of GDP) of Croatia?
Your answer should be very brief. -0.34. In the year 2008, what is the difference between the Rent(as % of GDP) of Australia and Rent(as % of GDP) of Lithuania?
Ensure brevity in your answer.  -0.49. In the year 2008, what is the difference between the Rent(as % of GDP) in Croatia and Rent(as % of GDP) in Lithuania?
Provide a short and direct response. -0.15. In the year 2009, what is the difference between the Rent(as % of GDP) of Pacific island small states and Rent(as % of GDP) of Australia?
Offer a terse response. 3.04. In the year 2009, what is the difference between the Rent(as % of GDP) in Pacific island small states and Rent(as % of GDP) in Croatia?
Give a very brief answer. 2.68. In the year 2009, what is the difference between the Rent(as % of GDP) in Pacific island small states and Rent(as % of GDP) in Lithuania?
Your answer should be very brief. 2.47. In the year 2009, what is the difference between the Rent(as % of GDP) in Australia and Rent(as % of GDP) in Croatia?
Your answer should be compact. -0.36. In the year 2009, what is the difference between the Rent(as % of GDP) of Australia and Rent(as % of GDP) of Lithuania?
Keep it short and to the point. -0.57. In the year 2009, what is the difference between the Rent(as % of GDP) in Croatia and Rent(as % of GDP) in Lithuania?
Give a very brief answer. -0.22. In the year 2010, what is the difference between the Rent(as % of GDP) in Pacific island small states and Rent(as % of GDP) in Australia?
Provide a succinct answer. 3.47. In the year 2010, what is the difference between the Rent(as % of GDP) of Pacific island small states and Rent(as % of GDP) of Croatia?
Your answer should be very brief. 2.96. In the year 2010, what is the difference between the Rent(as % of GDP) of Pacific island small states and Rent(as % of GDP) of Lithuania?
Ensure brevity in your answer.  2.5. In the year 2010, what is the difference between the Rent(as % of GDP) of Australia and Rent(as % of GDP) of Croatia?
Provide a short and direct response. -0.52. In the year 2010, what is the difference between the Rent(as % of GDP) in Australia and Rent(as % of GDP) in Lithuania?
Keep it short and to the point. -0.97. In the year 2010, what is the difference between the Rent(as % of GDP) of Croatia and Rent(as % of GDP) of Lithuania?
Your answer should be compact. -0.46. In the year 2011, what is the difference between the Rent(as % of GDP) of Pacific island small states and Rent(as % of GDP) of Australia?
Offer a very short reply. 3.99. In the year 2011, what is the difference between the Rent(as % of GDP) of Pacific island small states and Rent(as % of GDP) of Croatia?
Keep it short and to the point. 3.37. In the year 2011, what is the difference between the Rent(as % of GDP) of Pacific island small states and Rent(as % of GDP) of Lithuania?
Make the answer very short. 3.16. In the year 2011, what is the difference between the Rent(as % of GDP) of Australia and Rent(as % of GDP) of Croatia?
Ensure brevity in your answer.  -0.62. In the year 2011, what is the difference between the Rent(as % of GDP) of Australia and Rent(as % of GDP) of Lithuania?
Provide a short and direct response. -0.83. In the year 2011, what is the difference between the Rent(as % of GDP) in Croatia and Rent(as % of GDP) in Lithuania?
Ensure brevity in your answer.  -0.21. In the year 2012, what is the difference between the Rent(as % of GDP) in Pacific island small states and Rent(as % of GDP) in Australia?
Make the answer very short. 4.57. In the year 2012, what is the difference between the Rent(as % of GDP) of Pacific island small states and Rent(as % of GDP) of Croatia?
Offer a terse response. 3.81. In the year 2012, what is the difference between the Rent(as % of GDP) of Pacific island small states and Rent(as % of GDP) of Lithuania?
Ensure brevity in your answer.  3.73. In the year 2012, what is the difference between the Rent(as % of GDP) of Australia and Rent(as % of GDP) of Croatia?
Make the answer very short. -0.76. In the year 2012, what is the difference between the Rent(as % of GDP) of Australia and Rent(as % of GDP) of Lithuania?
Make the answer very short. -0.84. In the year 2012, what is the difference between the Rent(as % of GDP) in Croatia and Rent(as % of GDP) in Lithuania?
Your answer should be very brief. -0.08. What is the ratio of the Rent(as % of GDP) in Pacific island small states in 2005 to that in 2006?
Your answer should be compact. 0.62. What is the ratio of the Rent(as % of GDP) of Australia in 2005 to that in 2006?
Provide a succinct answer. 0.89. What is the ratio of the Rent(as % of GDP) in Croatia in 2005 to that in 2006?
Ensure brevity in your answer.  0.85. What is the ratio of the Rent(as % of GDP) in Lithuania in 2005 to that in 2006?
Ensure brevity in your answer.  1.02. What is the ratio of the Rent(as % of GDP) in Pacific island small states in 2005 to that in 2007?
Ensure brevity in your answer.  0.52. What is the ratio of the Rent(as % of GDP) in Australia in 2005 to that in 2007?
Keep it short and to the point. 0.78. What is the ratio of the Rent(as % of GDP) in Croatia in 2005 to that in 2007?
Your answer should be very brief. 0.79. What is the ratio of the Rent(as % of GDP) of Lithuania in 2005 to that in 2007?
Offer a terse response. 1.07. What is the ratio of the Rent(as % of GDP) of Pacific island small states in 2005 to that in 2008?
Your answer should be compact. 0.46. What is the ratio of the Rent(as % of GDP) in Australia in 2005 to that in 2008?
Offer a very short reply. 0.8. What is the ratio of the Rent(as % of GDP) of Croatia in 2005 to that in 2008?
Ensure brevity in your answer.  0.69. What is the ratio of the Rent(as % of GDP) in Lithuania in 2005 to that in 2008?
Your response must be concise. 1.14. What is the ratio of the Rent(as % of GDP) in Pacific island small states in 2005 to that in 2009?
Ensure brevity in your answer.  0.58. What is the ratio of the Rent(as % of GDP) in Australia in 2005 to that in 2009?
Keep it short and to the point. 0.9. What is the ratio of the Rent(as % of GDP) in Croatia in 2005 to that in 2009?
Provide a short and direct response. 0.71. What is the ratio of the Rent(as % of GDP) of Lithuania in 2005 to that in 2009?
Make the answer very short. 1.05. What is the ratio of the Rent(as % of GDP) of Pacific island small states in 2005 to that in 2010?
Ensure brevity in your answer.  0.51. What is the ratio of the Rent(as % of GDP) in Australia in 2005 to that in 2010?
Your answer should be very brief. 1.1. What is the ratio of the Rent(as % of GDP) of Croatia in 2005 to that in 2010?
Give a very brief answer. 0.57. What is the ratio of the Rent(as % of GDP) in Lithuania in 2005 to that in 2010?
Make the answer very short. 0.7. What is the ratio of the Rent(as % of GDP) of Pacific island small states in 2005 to that in 2011?
Provide a short and direct response. 0.45. What is the ratio of the Rent(as % of GDP) in Australia in 2005 to that in 2011?
Give a very brief answer. 1.28. What is the ratio of the Rent(as % of GDP) in Croatia in 2005 to that in 2011?
Offer a terse response. 0.5. What is the ratio of the Rent(as % of GDP) of Lithuania in 2005 to that in 2011?
Provide a succinct answer. 0.82. What is the ratio of the Rent(as % of GDP) of Pacific island small states in 2005 to that in 2012?
Ensure brevity in your answer.  0.4. What is the ratio of the Rent(as % of GDP) of Australia in 2005 to that in 2012?
Provide a short and direct response. 1.68. What is the ratio of the Rent(as % of GDP) in Croatia in 2005 to that in 2012?
Offer a very short reply. 0.44. What is the ratio of the Rent(as % of GDP) of Lithuania in 2005 to that in 2012?
Your answer should be compact. 0.84. What is the ratio of the Rent(as % of GDP) of Pacific island small states in 2006 to that in 2007?
Your answer should be very brief. 0.84. What is the ratio of the Rent(as % of GDP) of Australia in 2006 to that in 2007?
Provide a succinct answer. 0.88. What is the ratio of the Rent(as % of GDP) of Croatia in 2006 to that in 2007?
Ensure brevity in your answer.  0.93. What is the ratio of the Rent(as % of GDP) in Lithuania in 2006 to that in 2007?
Keep it short and to the point. 1.05. What is the ratio of the Rent(as % of GDP) of Pacific island small states in 2006 to that in 2008?
Your response must be concise. 0.74. What is the ratio of the Rent(as % of GDP) of Australia in 2006 to that in 2008?
Offer a very short reply. 0.89. What is the ratio of the Rent(as % of GDP) in Croatia in 2006 to that in 2008?
Your answer should be very brief. 0.82. What is the ratio of the Rent(as % of GDP) of Lithuania in 2006 to that in 2008?
Your answer should be very brief. 1.12. What is the ratio of the Rent(as % of GDP) of Pacific island small states in 2006 to that in 2009?
Make the answer very short. 0.94. What is the ratio of the Rent(as % of GDP) of Australia in 2006 to that in 2009?
Provide a succinct answer. 1.01. What is the ratio of the Rent(as % of GDP) of Croatia in 2006 to that in 2009?
Offer a terse response. 0.83. What is the ratio of the Rent(as % of GDP) of Lithuania in 2006 to that in 2009?
Provide a succinct answer. 1.03. What is the ratio of the Rent(as % of GDP) of Pacific island small states in 2006 to that in 2010?
Give a very brief answer. 0.84. What is the ratio of the Rent(as % of GDP) in Australia in 2006 to that in 2010?
Offer a very short reply. 1.24. What is the ratio of the Rent(as % of GDP) of Croatia in 2006 to that in 2010?
Your answer should be compact. 0.67. What is the ratio of the Rent(as % of GDP) of Lithuania in 2006 to that in 2010?
Provide a succinct answer. 0.68. What is the ratio of the Rent(as % of GDP) in Pacific island small states in 2006 to that in 2011?
Give a very brief answer. 0.73. What is the ratio of the Rent(as % of GDP) of Australia in 2006 to that in 2011?
Your answer should be very brief. 1.44. What is the ratio of the Rent(as % of GDP) of Croatia in 2006 to that in 2011?
Provide a short and direct response. 0.59. What is the ratio of the Rent(as % of GDP) of Lithuania in 2006 to that in 2011?
Your answer should be compact. 0.8. What is the ratio of the Rent(as % of GDP) of Pacific island small states in 2006 to that in 2012?
Make the answer very short. 0.65. What is the ratio of the Rent(as % of GDP) in Australia in 2006 to that in 2012?
Your answer should be compact. 1.89. What is the ratio of the Rent(as % of GDP) in Croatia in 2006 to that in 2012?
Provide a succinct answer. 0.51. What is the ratio of the Rent(as % of GDP) of Lithuania in 2006 to that in 2012?
Your response must be concise. 0.82. What is the ratio of the Rent(as % of GDP) in Pacific island small states in 2007 to that in 2008?
Offer a terse response. 0.88. What is the ratio of the Rent(as % of GDP) of Australia in 2007 to that in 2008?
Your response must be concise. 1.01. What is the ratio of the Rent(as % of GDP) in Croatia in 2007 to that in 2008?
Keep it short and to the point. 0.88. What is the ratio of the Rent(as % of GDP) in Lithuania in 2007 to that in 2008?
Offer a very short reply. 1.07. What is the ratio of the Rent(as % of GDP) of Pacific island small states in 2007 to that in 2009?
Offer a very short reply. 1.12. What is the ratio of the Rent(as % of GDP) in Australia in 2007 to that in 2009?
Offer a very short reply. 1.15. What is the ratio of the Rent(as % of GDP) in Croatia in 2007 to that in 2009?
Provide a succinct answer. 0.89. What is the ratio of the Rent(as % of GDP) of Lithuania in 2007 to that in 2009?
Provide a short and direct response. 0.98. What is the ratio of the Rent(as % of GDP) of Pacific island small states in 2007 to that in 2010?
Offer a terse response. 0.99. What is the ratio of the Rent(as % of GDP) in Australia in 2007 to that in 2010?
Your answer should be compact. 1.41. What is the ratio of the Rent(as % of GDP) of Croatia in 2007 to that in 2010?
Provide a short and direct response. 0.72. What is the ratio of the Rent(as % of GDP) in Lithuania in 2007 to that in 2010?
Offer a very short reply. 0.65. What is the ratio of the Rent(as % of GDP) in Pacific island small states in 2007 to that in 2011?
Provide a succinct answer. 0.87. What is the ratio of the Rent(as % of GDP) of Australia in 2007 to that in 2011?
Your answer should be very brief. 1.63. What is the ratio of the Rent(as % of GDP) in Croatia in 2007 to that in 2011?
Ensure brevity in your answer.  0.63. What is the ratio of the Rent(as % of GDP) in Lithuania in 2007 to that in 2011?
Provide a short and direct response. 0.77. What is the ratio of the Rent(as % of GDP) of Pacific island small states in 2007 to that in 2012?
Your answer should be very brief. 0.77. What is the ratio of the Rent(as % of GDP) in Australia in 2007 to that in 2012?
Provide a succinct answer. 2.14. What is the ratio of the Rent(as % of GDP) in Croatia in 2007 to that in 2012?
Offer a terse response. 0.55. What is the ratio of the Rent(as % of GDP) of Lithuania in 2007 to that in 2012?
Your response must be concise. 0.78. What is the ratio of the Rent(as % of GDP) of Pacific island small states in 2008 to that in 2009?
Give a very brief answer. 1.27. What is the ratio of the Rent(as % of GDP) in Australia in 2008 to that in 2009?
Your answer should be compact. 1.13. What is the ratio of the Rent(as % of GDP) in Croatia in 2008 to that in 2009?
Give a very brief answer. 1.02. What is the ratio of the Rent(as % of GDP) of Lithuania in 2008 to that in 2009?
Make the answer very short. 0.92. What is the ratio of the Rent(as % of GDP) of Pacific island small states in 2008 to that in 2010?
Offer a terse response. 1.13. What is the ratio of the Rent(as % of GDP) of Australia in 2008 to that in 2010?
Give a very brief answer. 1.39. What is the ratio of the Rent(as % of GDP) in Croatia in 2008 to that in 2010?
Your response must be concise. 0.82. What is the ratio of the Rent(as % of GDP) of Lithuania in 2008 to that in 2010?
Keep it short and to the point. 0.61. What is the ratio of the Rent(as % of GDP) in Pacific island small states in 2008 to that in 2011?
Your response must be concise. 0.99. What is the ratio of the Rent(as % of GDP) in Australia in 2008 to that in 2011?
Provide a short and direct response. 1.61. What is the ratio of the Rent(as % of GDP) in Croatia in 2008 to that in 2011?
Ensure brevity in your answer.  0.72. What is the ratio of the Rent(as % of GDP) in Lithuania in 2008 to that in 2011?
Give a very brief answer. 0.72. What is the ratio of the Rent(as % of GDP) of Pacific island small states in 2008 to that in 2012?
Your response must be concise. 0.87. What is the ratio of the Rent(as % of GDP) in Australia in 2008 to that in 2012?
Provide a short and direct response. 2.11. What is the ratio of the Rent(as % of GDP) of Croatia in 2008 to that in 2012?
Your answer should be compact. 0.63. What is the ratio of the Rent(as % of GDP) of Lithuania in 2008 to that in 2012?
Make the answer very short. 0.73. What is the ratio of the Rent(as % of GDP) in Pacific island small states in 2009 to that in 2010?
Keep it short and to the point. 0.89. What is the ratio of the Rent(as % of GDP) in Australia in 2009 to that in 2010?
Provide a short and direct response. 1.22. What is the ratio of the Rent(as % of GDP) of Croatia in 2009 to that in 2010?
Provide a succinct answer. 0.8. What is the ratio of the Rent(as % of GDP) of Lithuania in 2009 to that in 2010?
Your response must be concise. 0.66. What is the ratio of the Rent(as % of GDP) of Pacific island small states in 2009 to that in 2011?
Provide a short and direct response. 0.78. What is the ratio of the Rent(as % of GDP) in Australia in 2009 to that in 2011?
Keep it short and to the point. 1.42. What is the ratio of the Rent(as % of GDP) in Croatia in 2009 to that in 2011?
Offer a terse response. 0.7. What is the ratio of the Rent(as % of GDP) of Lithuania in 2009 to that in 2011?
Your answer should be very brief. 0.78. What is the ratio of the Rent(as % of GDP) of Pacific island small states in 2009 to that in 2012?
Provide a short and direct response. 0.69. What is the ratio of the Rent(as % of GDP) in Australia in 2009 to that in 2012?
Provide a short and direct response. 1.87. What is the ratio of the Rent(as % of GDP) in Croatia in 2009 to that in 2012?
Your response must be concise. 0.62. What is the ratio of the Rent(as % of GDP) in Lithuania in 2009 to that in 2012?
Your response must be concise. 0.79. What is the ratio of the Rent(as % of GDP) in Pacific island small states in 2010 to that in 2011?
Make the answer very short. 0.88. What is the ratio of the Rent(as % of GDP) of Australia in 2010 to that in 2011?
Your answer should be compact. 1.16. What is the ratio of the Rent(as % of GDP) in Croatia in 2010 to that in 2011?
Offer a very short reply. 0.88. What is the ratio of the Rent(as % of GDP) in Lithuania in 2010 to that in 2011?
Make the answer very short. 1.17. What is the ratio of the Rent(as % of GDP) of Pacific island small states in 2010 to that in 2012?
Your answer should be very brief. 0.77. What is the ratio of the Rent(as % of GDP) of Australia in 2010 to that in 2012?
Make the answer very short. 1.52. What is the ratio of the Rent(as % of GDP) of Croatia in 2010 to that in 2012?
Offer a terse response. 0.77. What is the ratio of the Rent(as % of GDP) of Lithuania in 2010 to that in 2012?
Make the answer very short. 1.2. What is the ratio of the Rent(as % of GDP) in Pacific island small states in 2011 to that in 2012?
Give a very brief answer. 0.88. What is the ratio of the Rent(as % of GDP) in Australia in 2011 to that in 2012?
Your response must be concise. 1.31. What is the ratio of the Rent(as % of GDP) in Croatia in 2011 to that in 2012?
Offer a terse response. 0.87. What is the ratio of the Rent(as % of GDP) of Lithuania in 2011 to that in 2012?
Your answer should be very brief. 1.02. What is the difference between the highest and the second highest Rent(as % of GDP) in Pacific island small states?
Make the answer very short. 0.55. What is the difference between the highest and the second highest Rent(as % of GDP) in Australia?
Your answer should be very brief. 0. What is the difference between the highest and the second highest Rent(as % of GDP) of Croatia?
Provide a short and direct response. 0.11. What is the difference between the highest and the second highest Rent(as % of GDP) of Lithuania?
Your response must be concise. 0.16. What is the difference between the highest and the lowest Rent(as % of GDP) of Pacific island small states?
Keep it short and to the point. 2.8. What is the difference between the highest and the lowest Rent(as % of GDP) in Australia?
Offer a terse response. 0.1. What is the difference between the highest and the lowest Rent(as % of GDP) of Croatia?
Make the answer very short. 0.48. What is the difference between the highest and the lowest Rent(as % of GDP) in Lithuania?
Offer a very short reply. 0.43. 